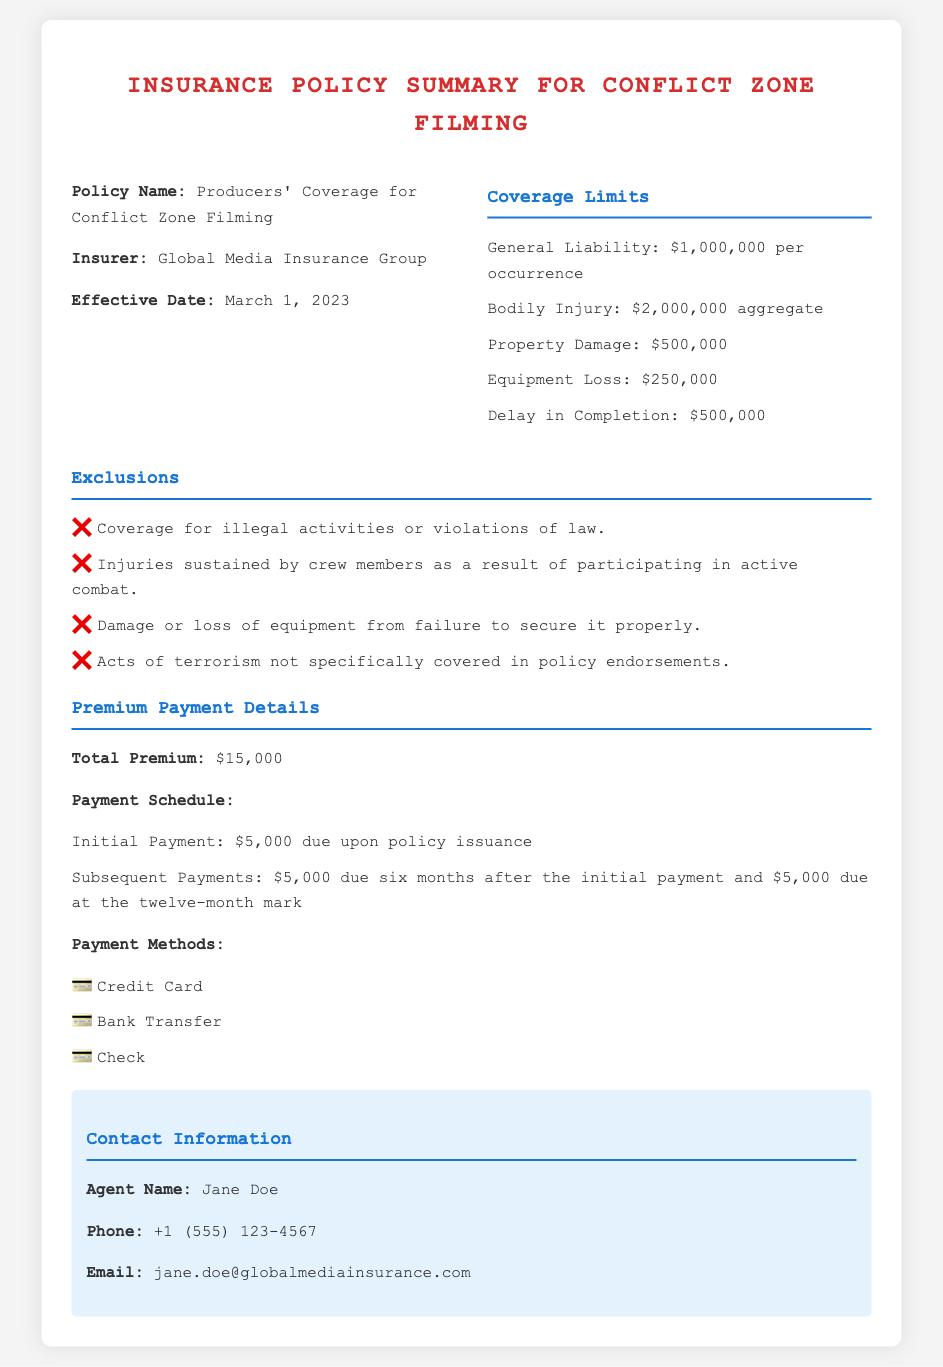What is the policy name? The policy name is explicitly stated at the beginning of the document as "Producers' Coverage for Conflict Zone Filming."
Answer: Producers' Coverage for Conflict Zone Filming What is the total premium amount? The total premium amount is highlighted in the premium payment details section of the document as $15,000.
Answer: $15,000 Who is the insurer? The insurer is clearly identified in the document as "Global Media Insurance Group."
Answer: Global Media Insurance Group What is the effective date of the policy? The effective date of the policy is mentioned in the document as March 1, 2023.
Answer: March 1, 2023 What is the liability coverage limit per occurrence? The liability coverage limit per occurrence is specified in the coverage limits section, which states it is $1,000,000.
Answer: $1,000,000 How many payments are in the premium payment schedule? The payment schedule specifies three distinct payments: an initial payment and two subsequent payments, leading to a total of three.
Answer: 3 What is excluded regarding crew member injuries? The document states that injuries sustained by crew members due to participating in active combat are excluded from coverage.
Answer: Active combat participation What payment methods are accepted? The payment methods accepted are detailed in the payment methods section, listing three options available for payment.
Answer: Credit Card, Bank Transfer, Check Who is the agent for this insurance policy? The agent's name is specifically mentioned in the contact information section as "Jane Doe."
Answer: Jane Doe 